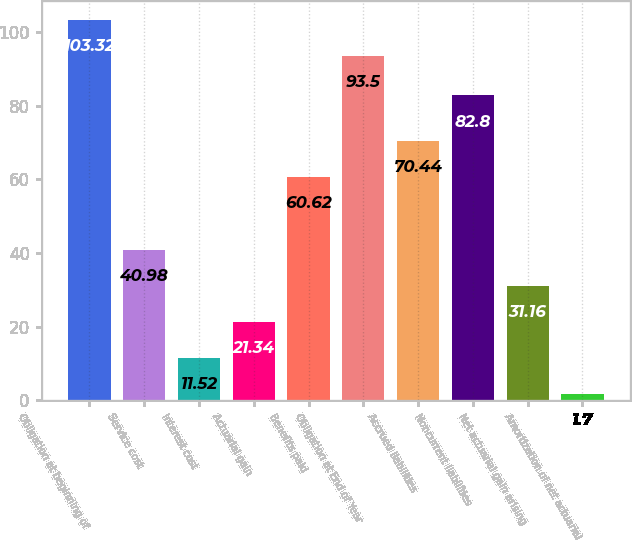Convert chart. <chart><loc_0><loc_0><loc_500><loc_500><bar_chart><fcel>Obligation at beginning of<fcel>Service cost<fcel>Interest cost<fcel>Actuarial gain<fcel>Benefits paid<fcel>Obligation at End of Year<fcel>Accrued liabilities<fcel>Noncurrent liabilities<fcel>Net actuarial gain arising<fcel>Amortization of net actuarial<nl><fcel>103.32<fcel>40.98<fcel>11.52<fcel>21.34<fcel>60.62<fcel>93.5<fcel>70.44<fcel>82.8<fcel>31.16<fcel>1.7<nl></chart> 